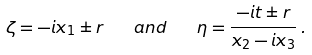Convert formula to latex. <formula><loc_0><loc_0><loc_500><loc_500>\zeta = - \i i x _ { 1 } \pm r \quad a n d \quad \eta = \frac { - \i i t \pm r } { x _ { 2 } - \i i x _ { 3 } } \, .</formula> 